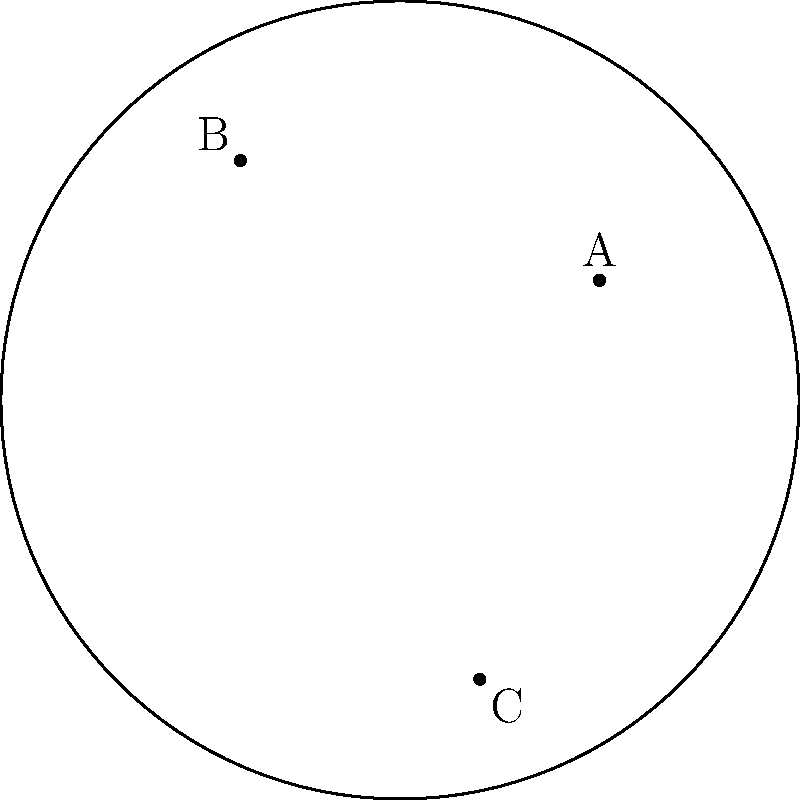In the Poincaré disk model of hyperbolic geometry shown above, three genetic markers A, B, and C are mapped based on their relative distances. If the hyperbolic distance between A and B is 1.2, B and C is 1.5, what is the approximate hyperbolic distance between A and C? To solve this problem, we need to follow these steps:

1) In the Poincaré disk model, distances are not preserved as in Euclidean geometry. The formula for the hyperbolic distance $d$ between two points $(x_1, y_1)$ and $(x_2, y_2)$ is:

   $$d = \text{acosh}(1 + \frac{2|z_1 - z_2|^2}{(1-|z_1|^2)(1-|z_2|^2)})$$

   where $z_1 = x_1 + iy_1$ and $z_2 = x_2 + iy_2$.

2) However, we don't need to use this formula directly. In hyperbolic geometry, the triangle inequality still holds, but with a twist. For any three points A, B, and C:

   $$d(A,C) \leq d(A,B) + d(B,C)$$

3) The equality holds when C is on the hyperbolic line between A and B. The maximum possible value for $d(A,C)$ is when A, B, and C form a straight line in hyperbolic space.

4) Given:
   $d(A,B) = 1.2$
   $d(B,C) = 1.5$

5) Therefore, the range for $d(A,C)$ is:

   $$|d(A,B) - d(B,C)| \leq d(A,C) \leq d(A,B) + d(B,C)$$
   $$|1.2 - 1.5| \leq d(A,C) \leq 1.2 + 1.5$$
   $$0.3 \leq d(A,C) \leq 2.7$$

6) From the diagram, we can see that A, B, and C do not form a straight line in hyperbolic space. Therefore, $d(A,C)$ will be less than the maximum value of 2.7.

7) A reasonable estimate would be somewhere in the middle of this range, around 1.5.
Answer: Approximately 1.5 